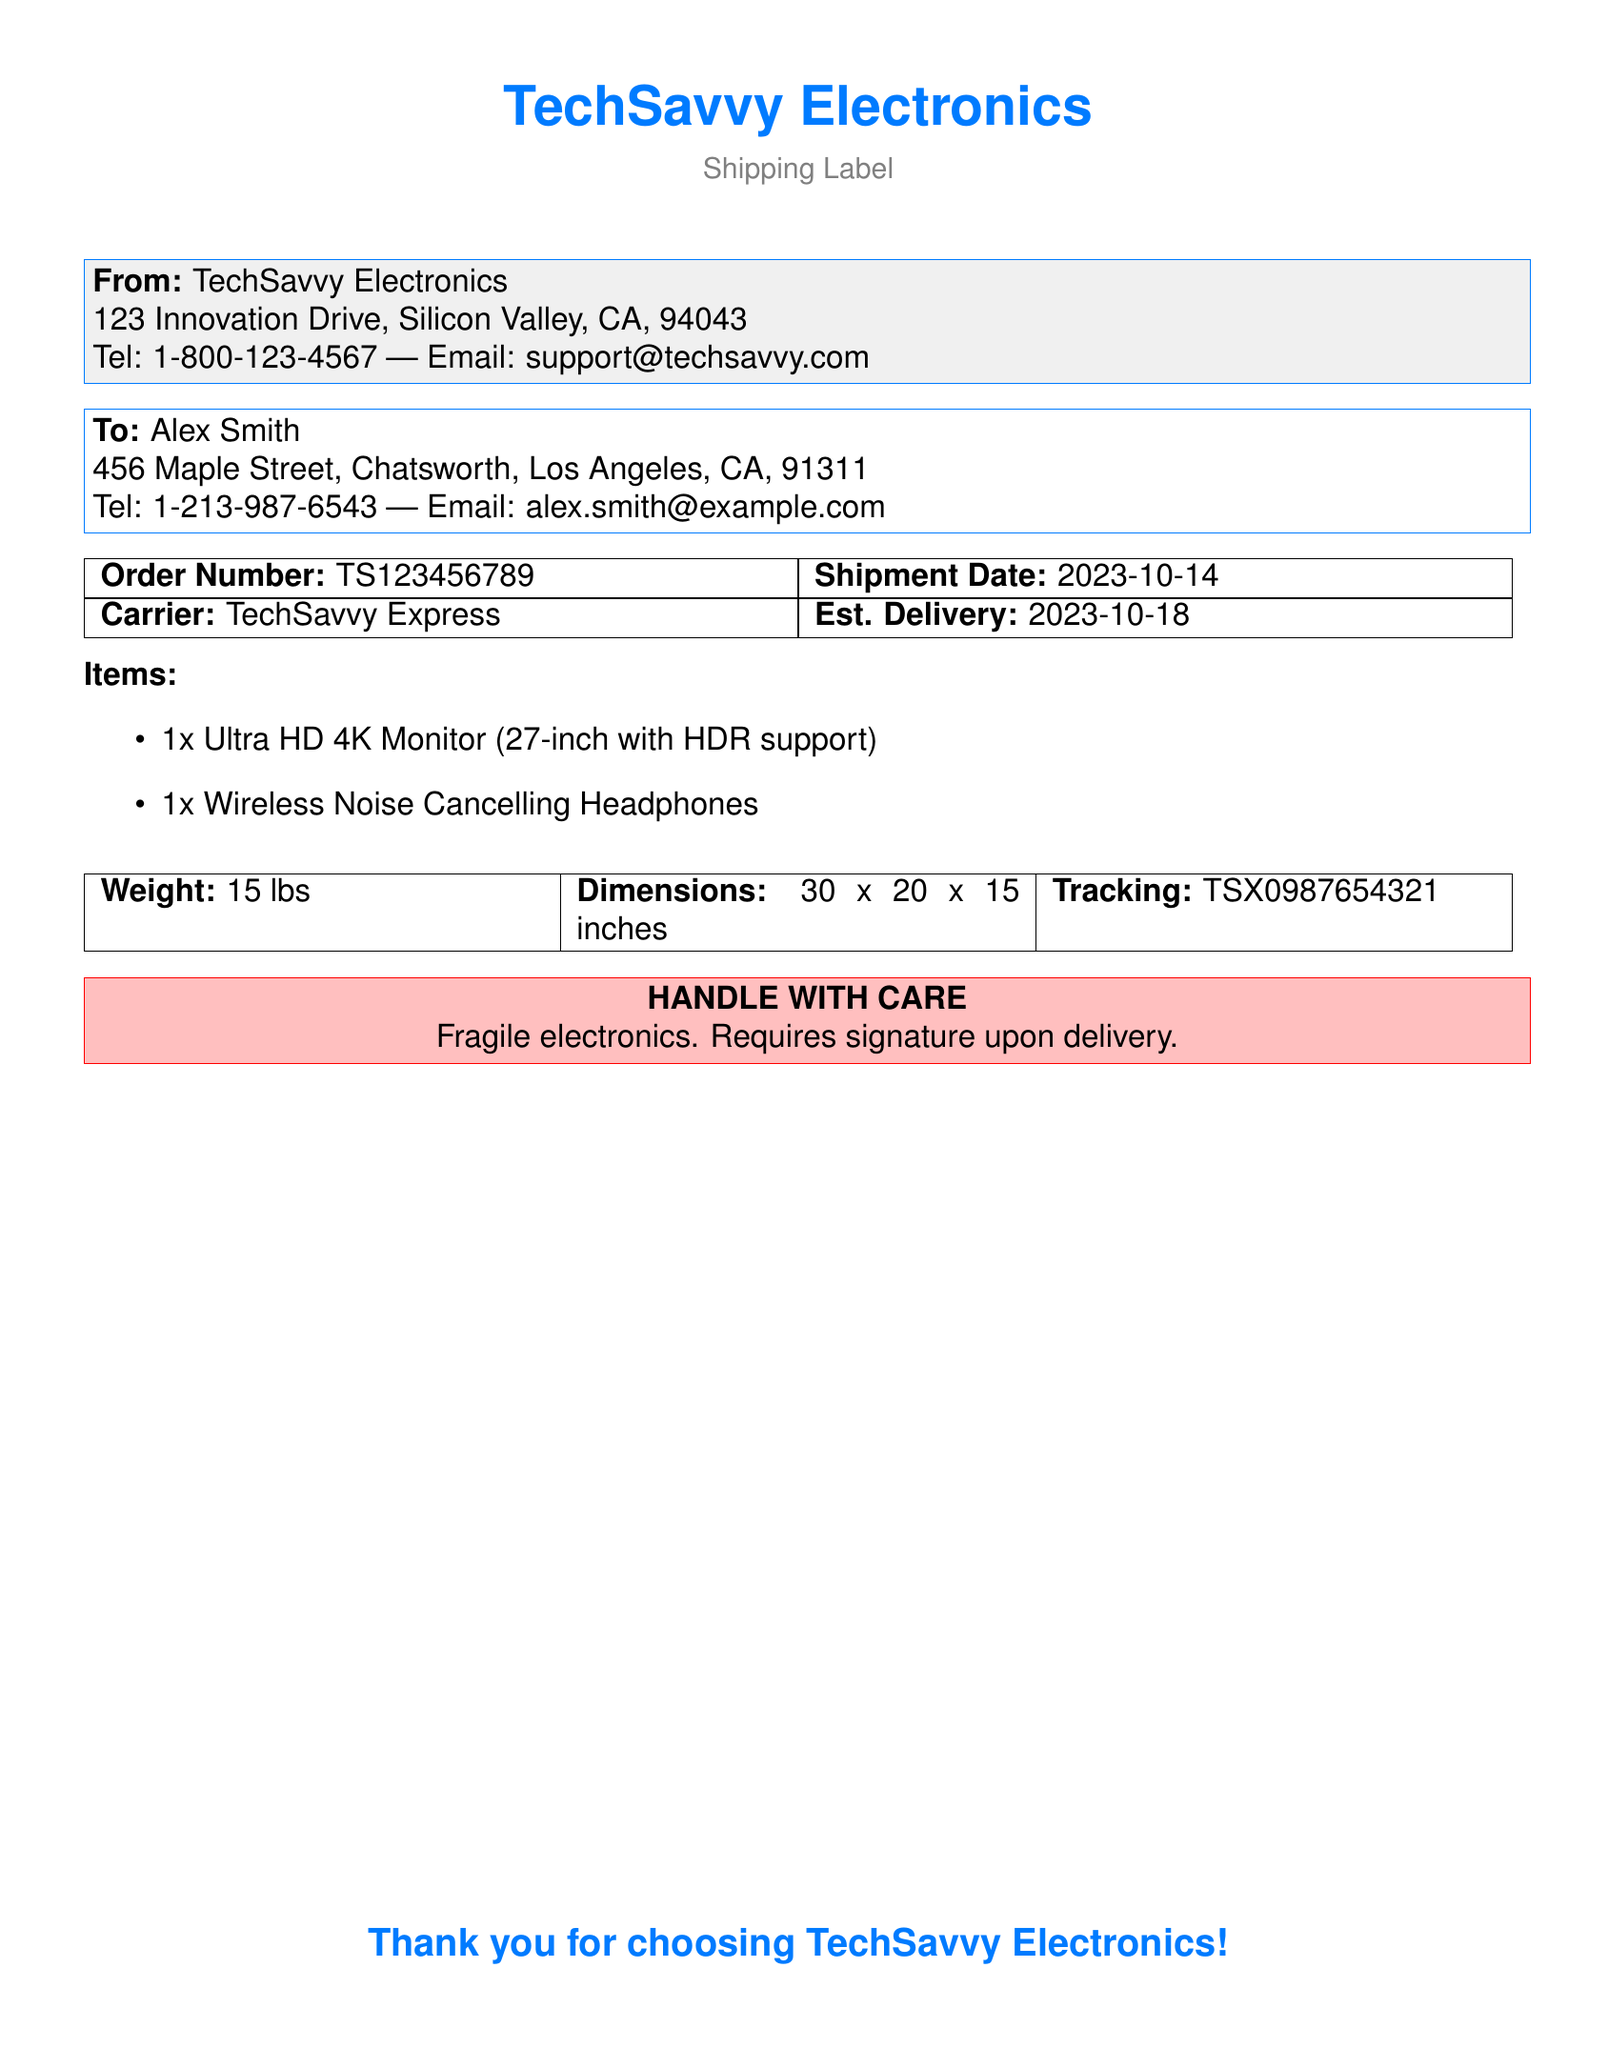What is the order number? The order number is a unique identifier for the shipment mentioned in the document.
Answer: TS123456789 Who is the sender? The sender's name and details are provided at the top of the shipping label.
Answer: TechSavvy Electronics What is the estimated delivery date? The estimated delivery date indicates when the package is expected to arrive.
Answer: 2023-10-18 How many items are included in the shipment? The items listed show the quantity of products being sent.
Answer: 2 What is the weight of the package? The weight is specified to inform about the heaviness of the shipment for handling purposes.
Answer: 15 lbs What is the recipient's address? The recipient's address is provided for proper delivery of the shipment.
Answer: 456 Maple Street, Chatsworth, Los Angeles, CA, 91311 What type of items were shipped? The items listed give information about the products included in the delivery.
Answer: Ultra HD 4K Monitor and Wireless Noise Cancelling Headphones What color is the handle with care box? The color gives important information regarding special handling instructions.
Answer: Pink What carrier is used for the shipment? The carrier name provides information about who is delivering the package.
Answer: TechSavvy Express 